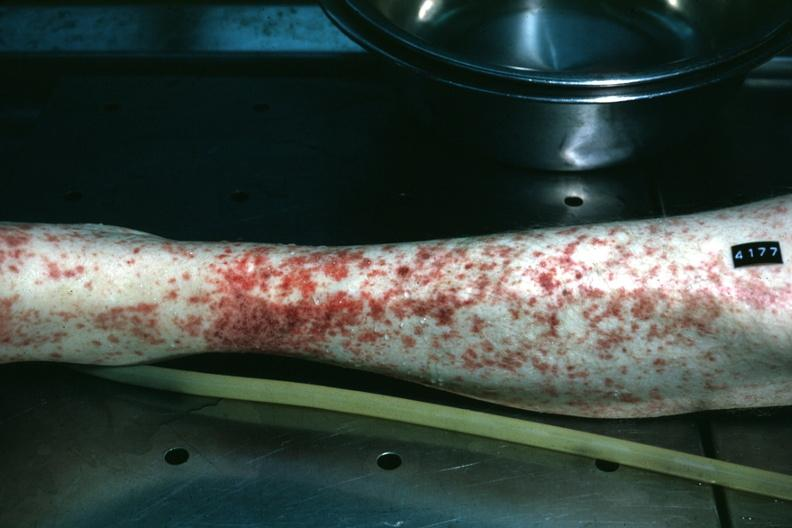what does this image show?
Answer the question using a single word or phrase. Leg excellent example of skin hemorrhages 